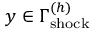<formula> <loc_0><loc_0><loc_500><loc_500>y \in \Gamma _ { s h o c k } ^ { ( h ) }</formula> 